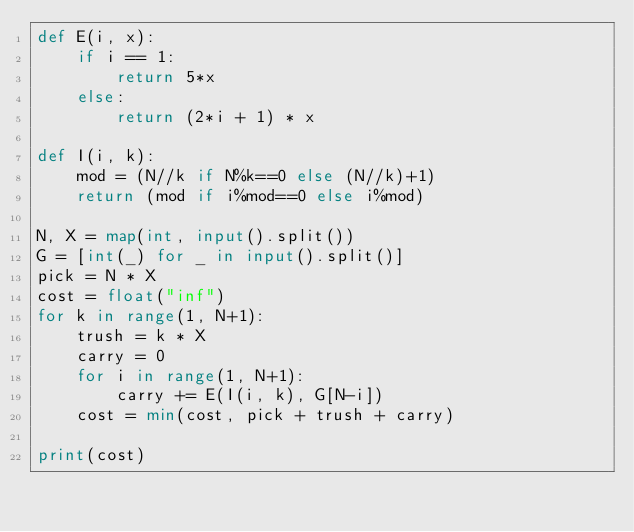Convert code to text. <code><loc_0><loc_0><loc_500><loc_500><_Python_>def E(i, x):
    if i == 1:
        return 5*x
    else:
        return (2*i + 1) * x

def I(i, k):
    mod = (N//k if N%k==0 else (N//k)+1)
    return (mod if i%mod==0 else i%mod)

N, X = map(int, input().split())
G = [int(_) for _ in input().split()]
pick = N * X
cost = float("inf")
for k in range(1, N+1):
    trush = k * X
    carry = 0
    for i in range(1, N+1):
        carry += E(I(i, k), G[N-i])
    cost = min(cost, pick + trush + carry)

print(cost)</code> 